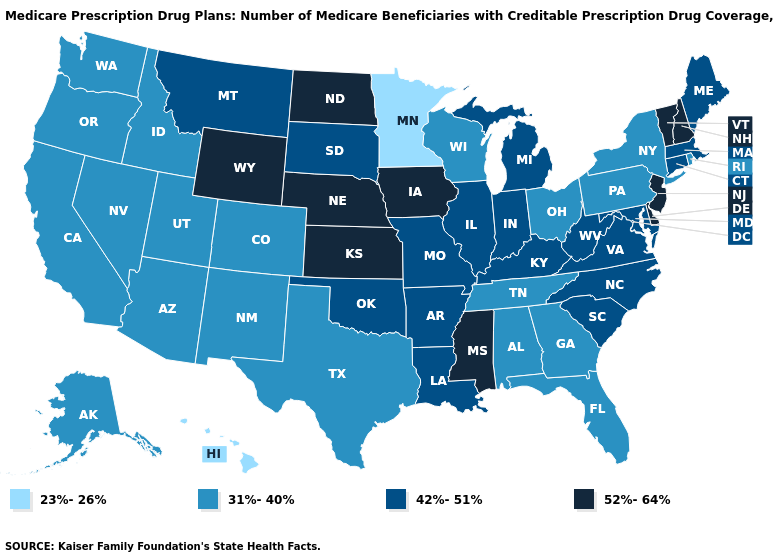Among the states that border Wisconsin , does Minnesota have the highest value?
Keep it brief. No. Does Michigan have the same value as Colorado?
Write a very short answer. No. Name the states that have a value in the range 31%-40%?
Short answer required. Alabama, Alaska, Arizona, California, Colorado, Florida, Georgia, Idaho, Nevada, New Mexico, New York, Ohio, Oregon, Pennsylvania, Rhode Island, Tennessee, Texas, Utah, Washington, Wisconsin. Name the states that have a value in the range 42%-51%?
Give a very brief answer. Arkansas, Connecticut, Illinois, Indiana, Kentucky, Louisiana, Maine, Maryland, Massachusetts, Michigan, Missouri, Montana, North Carolina, Oklahoma, South Carolina, South Dakota, Virginia, West Virginia. Does Louisiana have the same value as Wyoming?
Write a very short answer. No. Name the states that have a value in the range 42%-51%?
Short answer required. Arkansas, Connecticut, Illinois, Indiana, Kentucky, Louisiana, Maine, Maryland, Massachusetts, Michigan, Missouri, Montana, North Carolina, Oklahoma, South Carolina, South Dakota, Virginia, West Virginia. What is the value of New York?
Write a very short answer. 31%-40%. Among the states that border Ohio , which have the highest value?
Be succinct. Indiana, Kentucky, Michigan, West Virginia. Does New York have the lowest value in the Northeast?
Keep it brief. Yes. How many symbols are there in the legend?
Answer briefly. 4. What is the value of North Dakota?
Answer briefly. 52%-64%. How many symbols are there in the legend?
Quick response, please. 4. Name the states that have a value in the range 42%-51%?
Concise answer only. Arkansas, Connecticut, Illinois, Indiana, Kentucky, Louisiana, Maine, Maryland, Massachusetts, Michigan, Missouri, Montana, North Carolina, Oklahoma, South Carolina, South Dakota, Virginia, West Virginia. Does the first symbol in the legend represent the smallest category?
Short answer required. Yes. Name the states that have a value in the range 31%-40%?
Keep it brief. Alabama, Alaska, Arizona, California, Colorado, Florida, Georgia, Idaho, Nevada, New Mexico, New York, Ohio, Oregon, Pennsylvania, Rhode Island, Tennessee, Texas, Utah, Washington, Wisconsin. 